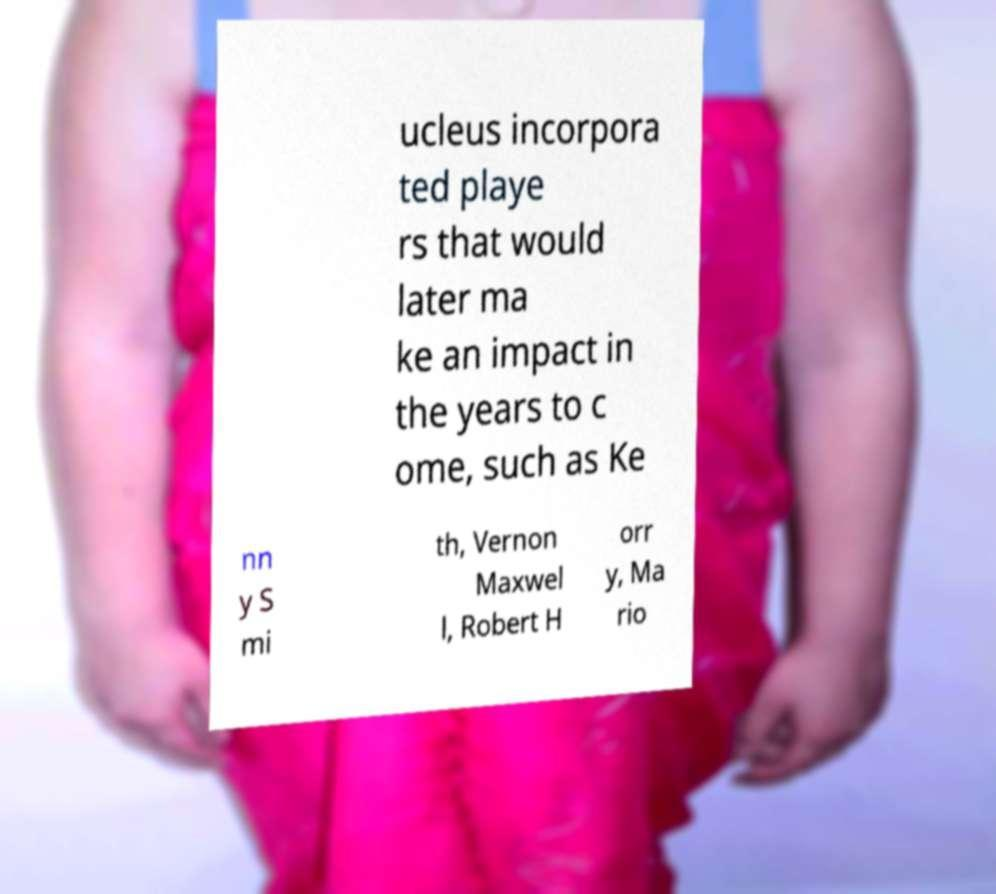What messages or text are displayed in this image? I need them in a readable, typed format. ucleus incorpora ted playe rs that would later ma ke an impact in the years to c ome, such as Ke nn y S mi th, Vernon Maxwel l, Robert H orr y, Ma rio 